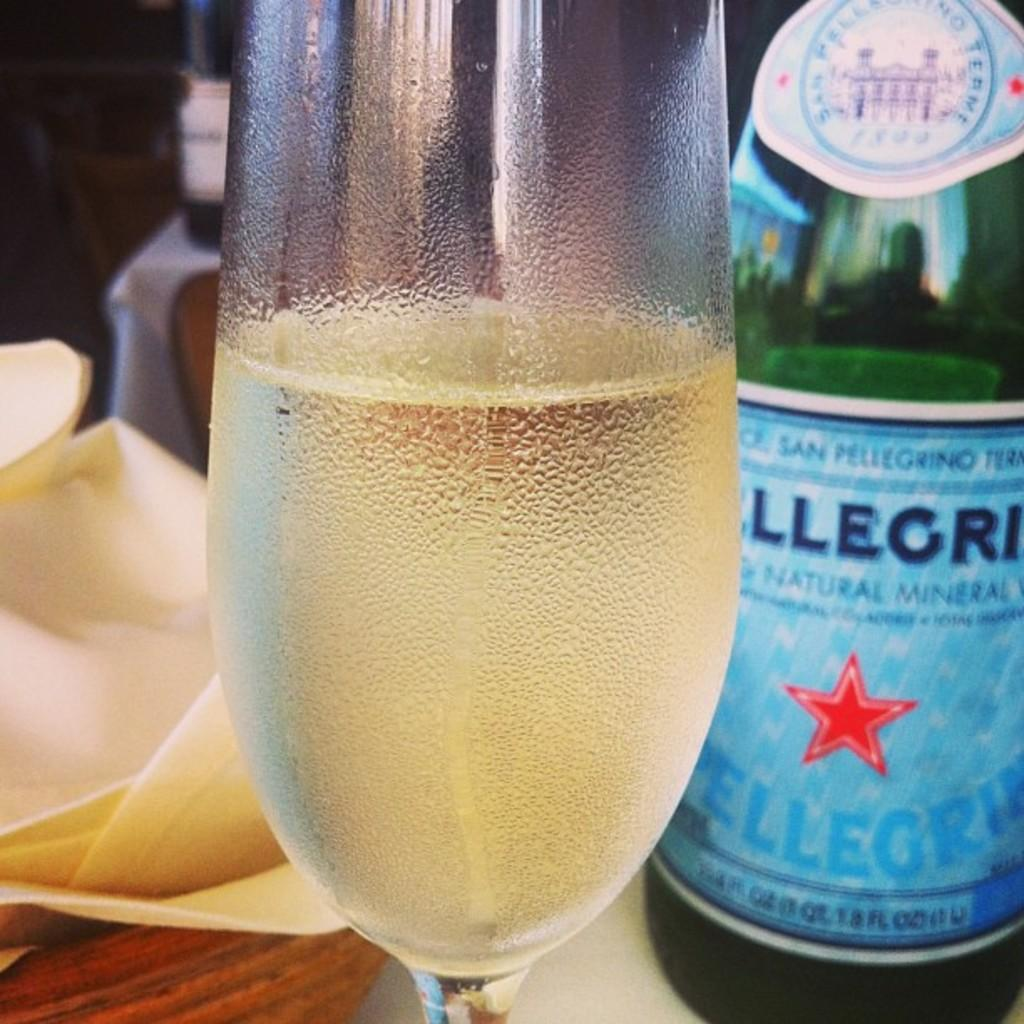Provide a one-sentence caption for the provided image. A bottle of San Pelligrino behind a glass. 